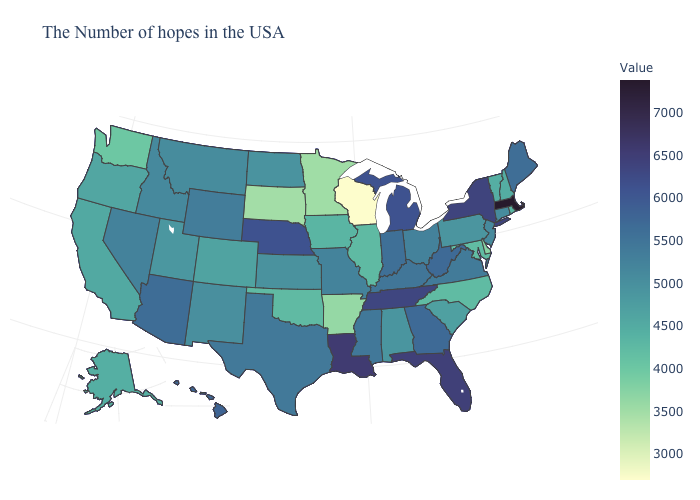Does Washington have the lowest value in the West?
Write a very short answer. Yes. Does Tennessee have a lower value than Massachusetts?
Be succinct. Yes. Does Missouri have the highest value in the USA?
Keep it brief. No. Among the states that border Nevada , does California have the lowest value?
Short answer required. Yes. Does Minnesota have the lowest value in the USA?
Answer briefly. No. 